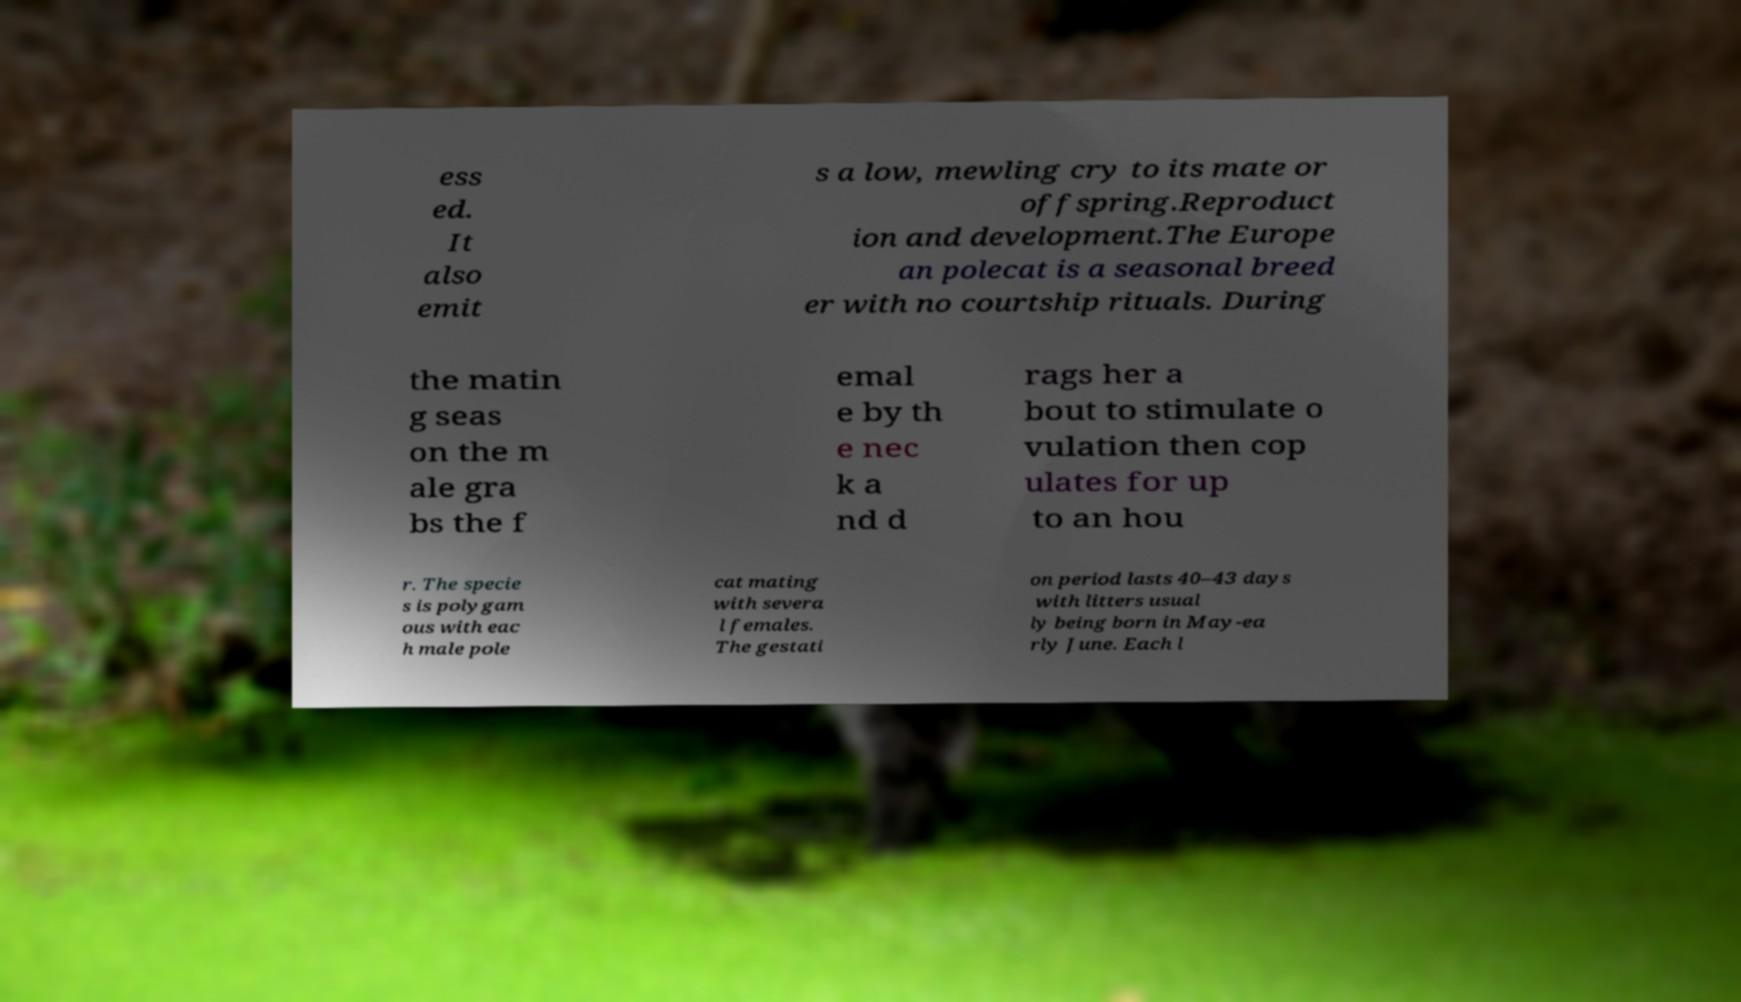Can you read and provide the text displayed in the image?This photo seems to have some interesting text. Can you extract and type it out for me? ess ed. It also emit s a low, mewling cry to its mate or offspring.Reproduct ion and development.The Europe an polecat is a seasonal breed er with no courtship rituals. During the matin g seas on the m ale gra bs the f emal e by th e nec k a nd d rags her a bout to stimulate o vulation then cop ulates for up to an hou r. The specie s is polygam ous with eac h male pole cat mating with severa l females. The gestati on period lasts 40–43 days with litters usual ly being born in May-ea rly June. Each l 